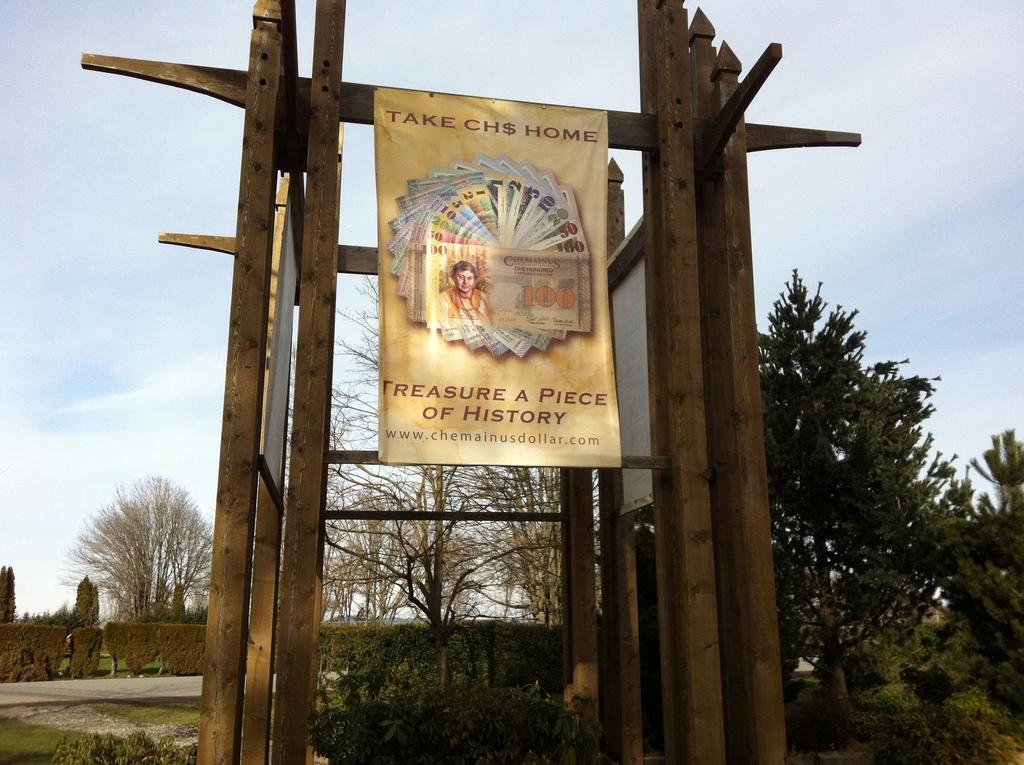Could you give a brief overview of what you see in this image? In the center of the image there is a poster on the wooden frame. In the background of the image there are trees. There is sky. At the bottom of the image there are plants. 